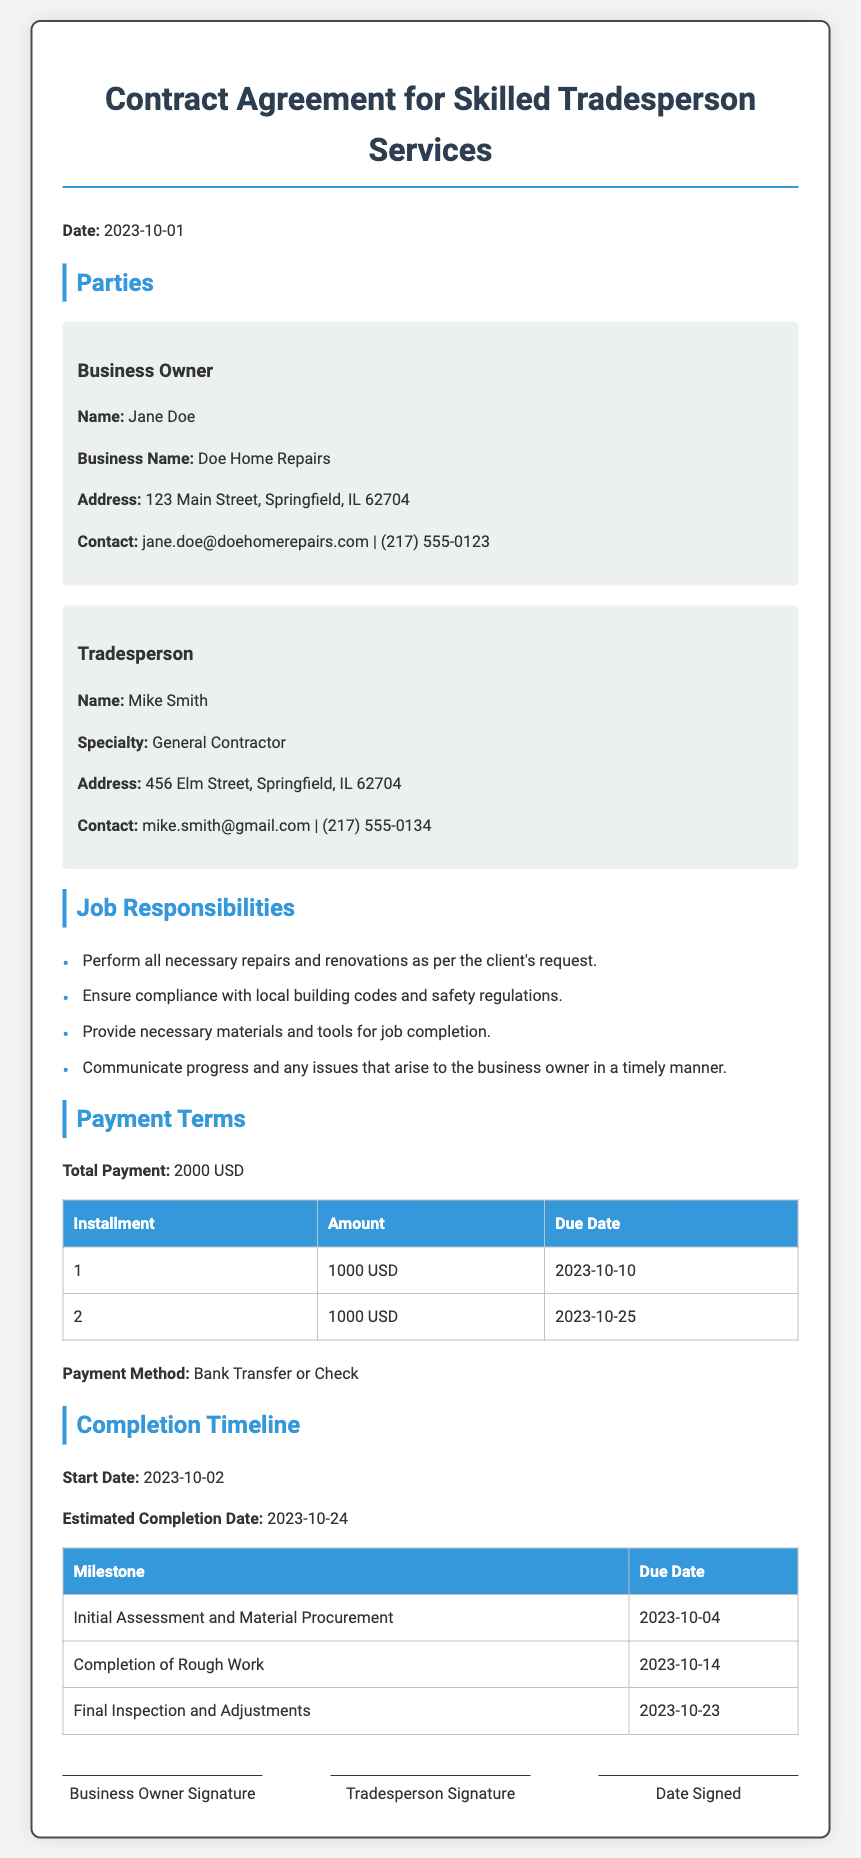What is the name of the business owner? The business owner's name is stated in the document under the party information section.
Answer: Jane Doe What is the total payment amount? The total payment is specifically mentioned in the Payment Terms section of the document.
Answer: 2000 USD When is the first installment due? The due date for the first installment is listed in the payment schedule table.
Answer: 2023-10-10 What is the specialty of the tradesperson? The tradesperson's specialty is provided in the party information section.
Answer: General Contractor What is the estimated completion date? The estimated completion date is noted in the Completion Timeline section of the document.
Answer: 2023-10-24 What is the payment method specified? The payment method is clearly mentioned in the Payment Terms section of the document.
Answer: Bank Transfer or Check Which milestone is due on 2023-10-14? The milestones with their due dates can be found in the completion timeline table.
Answer: Completion of Rough Work Who is responsible for ensuring compliance with building codes? Job responsibilities assign this task to the tradesperson according to the document.
Answer: Tradesperson What is the address of the business owner? The address can be found in the party information section of the document.
Answer: 123 Main Street, Springfield, IL 62704 